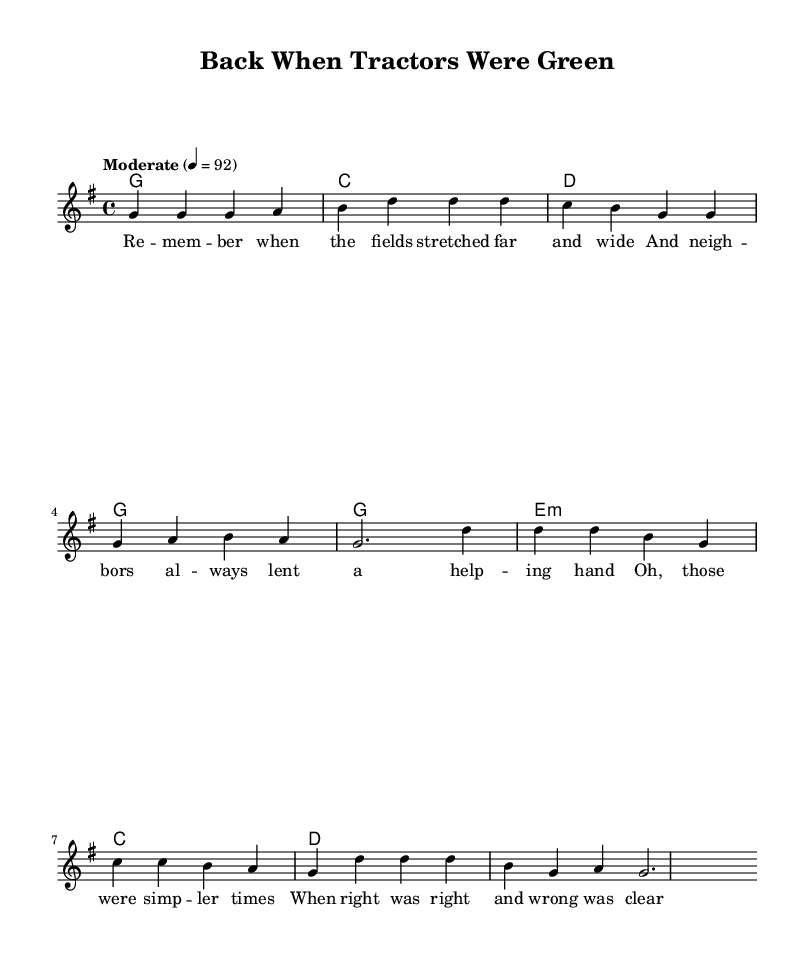What is the key signature of this music? The key signature can be found in the beginning of the sheet music. It shows one sharp, indicating the key is G major, which consists of the notes G, A, B, C, D, E, and F#.
Answer: G major What is the time signature of this composition? The time signature is indicated at the beginning of the music, showing a 4 over 4, which means there are four beats in a measure and the quarter note gets one beat.
Answer: 4/4 What is the tempo marking for this piece? The tempo marking is found above the staff, indicating a moderate speed of 92 beats per minute. This guides the performance pace.
Answer: Moderate, 92 What chord follows the first line of the verse? Looking at the harmonies, the first chord is marked as G, which is placed just above the note where the verse begins.
Answer: G How many measures are in the chorus section? The chorus consists of four distinct measures, evidenced by the spacing and grouping of the notes. Each measure is separated visually in the sheet music.
Answer: 4 What lyrical theme is presented in the chorus? The lyrics of the chorus reflect a nostalgic theme, recalling simpler times and the clarity of right and wrong, as expressed in the provided words.
Answer: Simpler times 